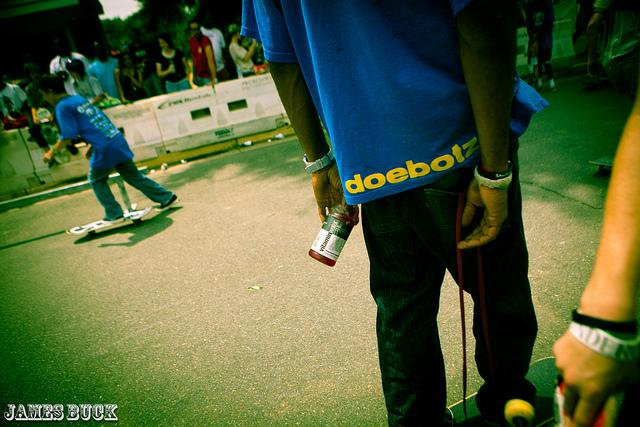What flavoured beverage is in the bottle?

Choices:
A) soda
B) beer
C) water
D) wine water 